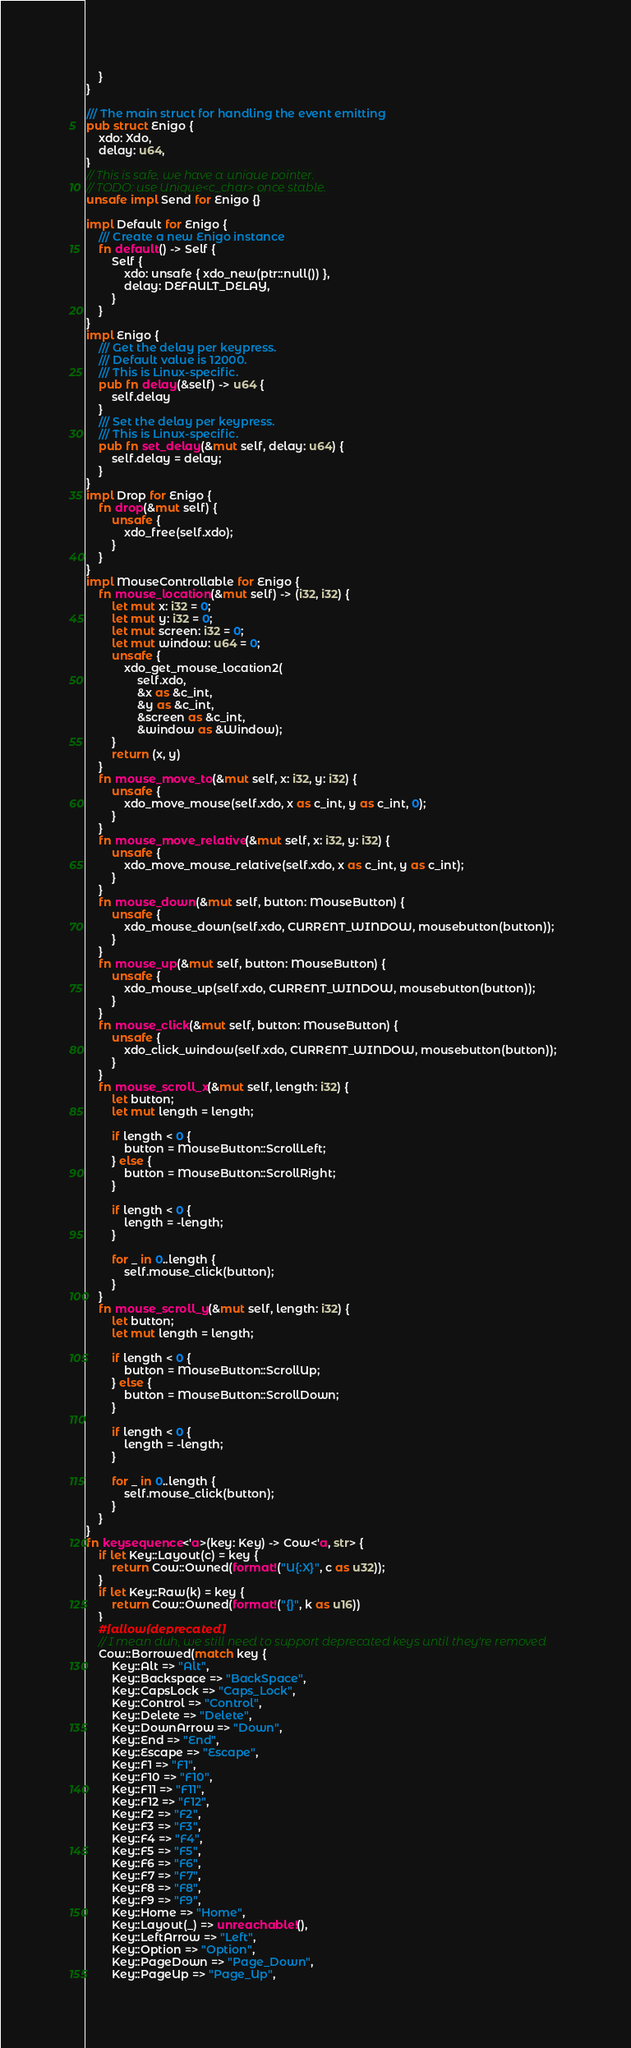<code> <loc_0><loc_0><loc_500><loc_500><_Rust_>    }
}

/// The main struct for handling the event emitting
pub struct Enigo {
    xdo: Xdo,
    delay: u64,
}
// This is safe, we have a unique pointer.
// TODO: use Unique<c_char> once stable.
unsafe impl Send for Enigo {}

impl Default for Enigo {
    /// Create a new Enigo instance
    fn default() -> Self {
        Self {
            xdo: unsafe { xdo_new(ptr::null()) },
            delay: DEFAULT_DELAY,
        }
    }
}
impl Enigo {
    /// Get the delay per keypress.
    /// Default value is 12000.
    /// This is Linux-specific.
    pub fn delay(&self) -> u64 {
        self.delay
    }
    /// Set the delay per keypress.
    /// This is Linux-specific.
    pub fn set_delay(&mut self, delay: u64) {
        self.delay = delay;
    }
}
impl Drop for Enigo {
    fn drop(&mut self) {
        unsafe {
            xdo_free(self.xdo);
        }
    }
}
impl MouseControllable for Enigo {
    fn mouse_location(&mut self) -> (i32, i32) {
        let mut x: i32 = 0;
        let mut y: i32 = 0;
        let mut screen: i32 = 0;
        let mut window: u64 = 0;
        unsafe {
            xdo_get_mouse_location2(
                self.xdo,
                &x as &c_int,
                &y as &c_int,
                &screen as &c_int,
                &window as &Window);
        }
        return (x, y)
    }
    fn mouse_move_to(&mut self, x: i32, y: i32) {
        unsafe {
            xdo_move_mouse(self.xdo, x as c_int, y as c_int, 0);
        }
    }
    fn mouse_move_relative(&mut self, x: i32, y: i32) {
        unsafe {
            xdo_move_mouse_relative(self.xdo, x as c_int, y as c_int);
        }
    }
    fn mouse_down(&mut self, button: MouseButton) {
        unsafe {
            xdo_mouse_down(self.xdo, CURRENT_WINDOW, mousebutton(button));
        }
    }
    fn mouse_up(&mut self, button: MouseButton) {
        unsafe {
            xdo_mouse_up(self.xdo, CURRENT_WINDOW, mousebutton(button));
        }
    }
    fn mouse_click(&mut self, button: MouseButton) {
        unsafe {
            xdo_click_window(self.xdo, CURRENT_WINDOW, mousebutton(button));
        }
    }
    fn mouse_scroll_x(&mut self, length: i32) {
        let button;
        let mut length = length;

        if length < 0 {
            button = MouseButton::ScrollLeft;
        } else {
            button = MouseButton::ScrollRight;
        }

        if length < 0 {
            length = -length;
        }

        for _ in 0..length {
            self.mouse_click(button);
        }
    }
    fn mouse_scroll_y(&mut self, length: i32) {
        let button;
        let mut length = length;

        if length < 0 {
            button = MouseButton::ScrollUp;
        } else {
            button = MouseButton::ScrollDown;
        }

        if length < 0 {
            length = -length;
        }

        for _ in 0..length {
            self.mouse_click(button);
        }
    }
}
fn keysequence<'a>(key: Key) -> Cow<'a, str> {
    if let Key::Layout(c) = key {
        return Cow::Owned(format!("U{:X}", c as u32));
    }
    if let Key::Raw(k) = key {
        return Cow::Owned(format!("{}", k as u16))
    }
    #[allow(deprecated)]
    // I mean duh, we still need to support deprecated keys until they're removed
    Cow::Borrowed(match key {
        Key::Alt => "Alt",
        Key::Backspace => "BackSpace",
        Key::CapsLock => "Caps_Lock",
        Key::Control => "Control",
        Key::Delete => "Delete",
        Key::DownArrow => "Down",
        Key::End => "End",
        Key::Escape => "Escape",
        Key::F1 => "F1",
        Key::F10 => "F10",
        Key::F11 => "F11",
        Key::F12 => "F12",
        Key::F2 => "F2",
        Key::F3 => "F3",
        Key::F4 => "F4",
        Key::F5 => "F5",
        Key::F6 => "F6",
        Key::F7 => "F7",
        Key::F8 => "F8",
        Key::F9 => "F9",
        Key::Home => "Home",
        Key::Layout(_) => unreachable!(),
        Key::LeftArrow => "Left",
        Key::Option => "Option",
        Key::PageDown => "Page_Down",
        Key::PageUp => "Page_Up",</code> 